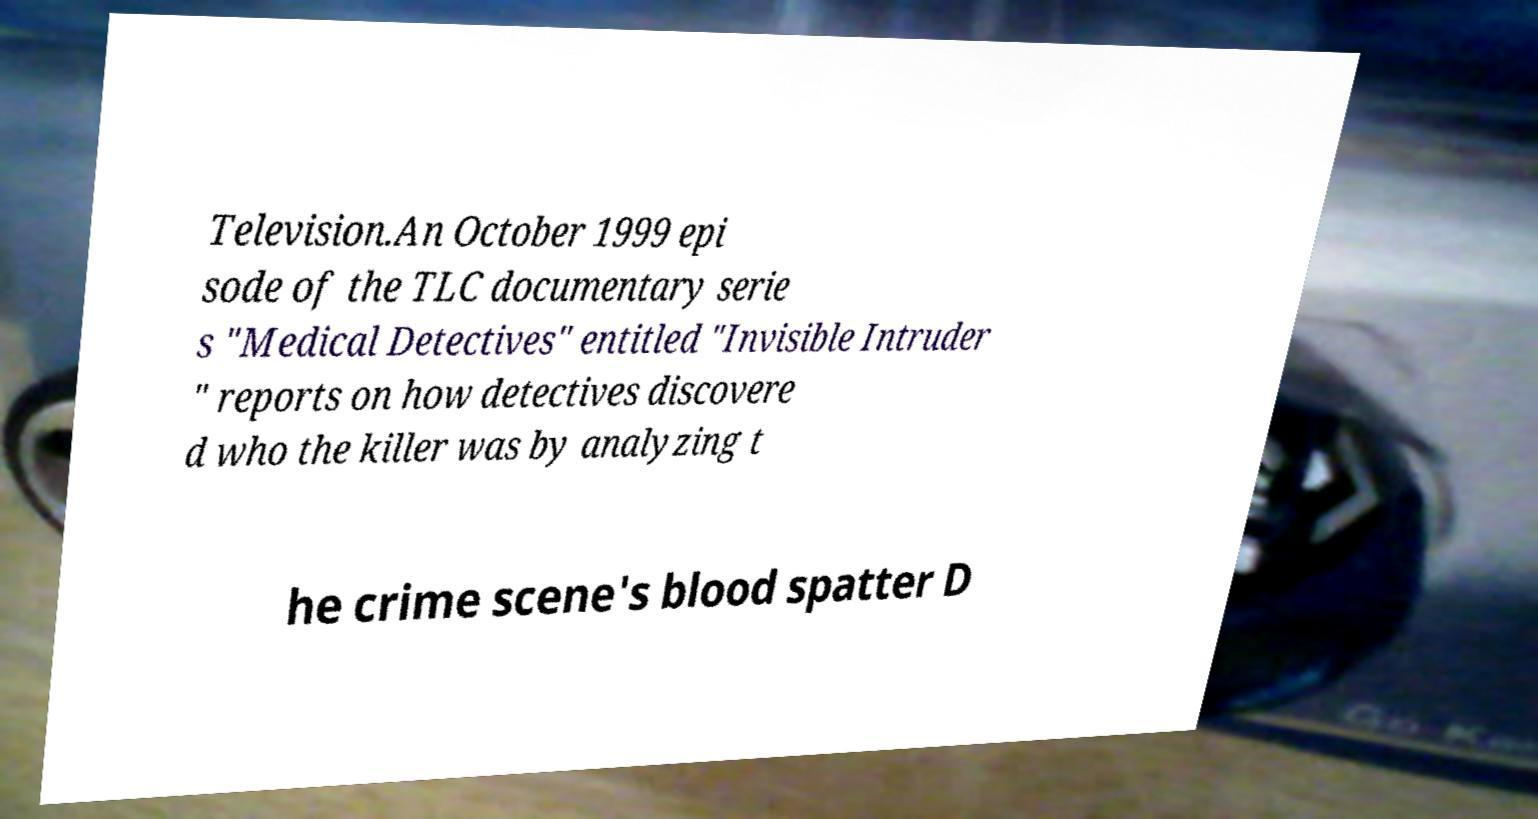What messages or text are displayed in this image? I need them in a readable, typed format. Television.An October 1999 epi sode of the TLC documentary serie s "Medical Detectives" entitled "Invisible Intruder " reports on how detectives discovere d who the killer was by analyzing t he crime scene's blood spatter D 